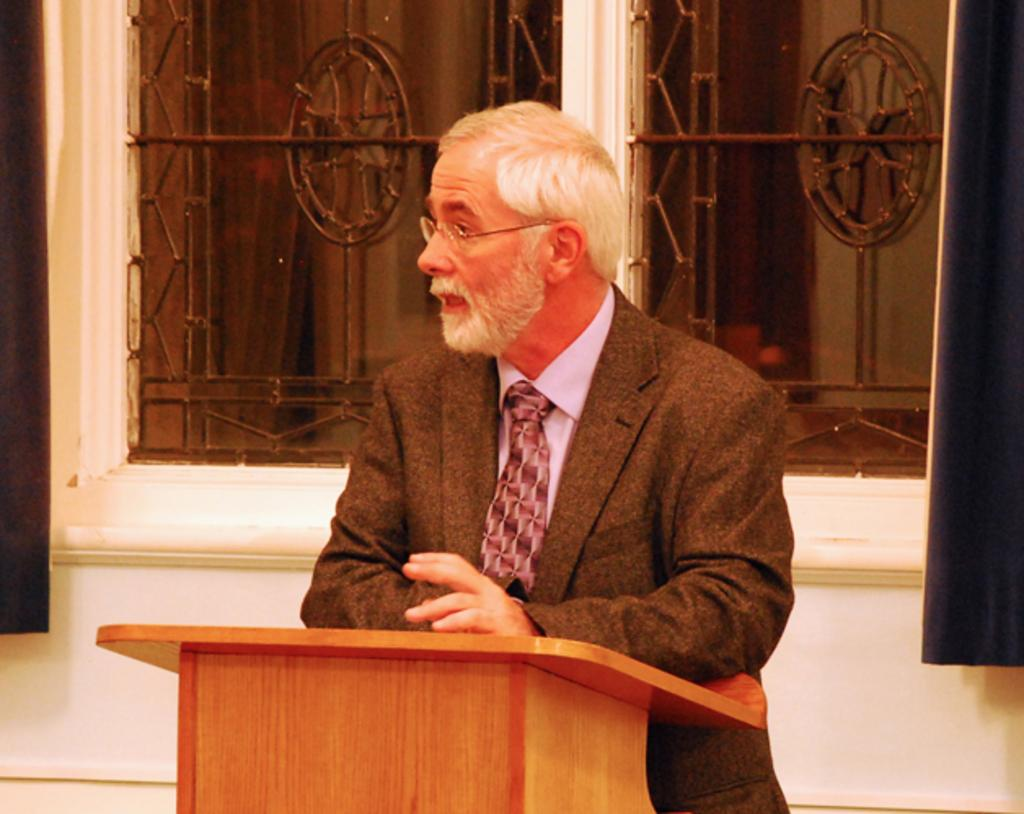What is the main subject of the image? There is a man standing in the center of the image. Where is the man positioned in relation to the podium? The man is standing near a podium. Can you describe the man's appearance? The man is wearing glasses. What can be seen in the background of the image? There is a window behind the man, and a curtain is associated with the window. What type of rice can be seen on the slope in the image? There is no rice or slope present in the image; it features a man standing near a podium. What is the aftermath of the event depicted in the image? The image does not depict an event, so there is no aftermath to describe. 